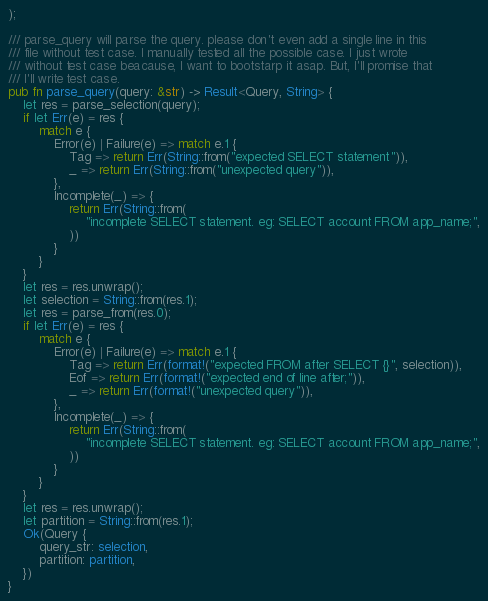Convert code to text. <code><loc_0><loc_0><loc_500><loc_500><_Rust_>);

/// parse_query will parse the query. please don't even add a single line in this
/// file without test case. I manually tested all the possible case. I just wrote
/// without test case beacause, I want to bootstarp it asap. But, I'll promise that
/// I'll write test case.
pub fn parse_query(query: &str) -> Result<Query, String> {
    let res = parse_selection(query);
    if let Err(e) = res {
        match e {
            Error(e) | Failure(e) => match e.1 {
                Tag => return Err(String::from("expected SELECT statement")),
                _ => return Err(String::from("unexpected query")),
            },
            Incomplete(_) => {
                return Err(String::from(
                    "incomplete SELECT statement. eg: SELECT account FROM app_name;",
                ))
            }
        }
    }
    let res = res.unwrap();
    let selection = String::from(res.1);
    let res = parse_from(res.0);
    if let Err(e) = res {
        match e {
            Error(e) | Failure(e) => match e.1 {
                Tag => return Err(format!("expected FROM after SELECT {}", selection)),
                Eof => return Err(format!("expected end of line after;")),
                _ => return Err(format!("unexpected query")),
            },
            Incomplete(_) => {
                return Err(String::from(
                    "incomplete SELECT statement. eg: SELECT account FROM app_name;",
                ))
            }
        }
    }
    let res = res.unwrap();
    let partition = String::from(res.1);
    Ok(Query {
        query_str: selection,
        partition: partition,
    })
}
</code> 